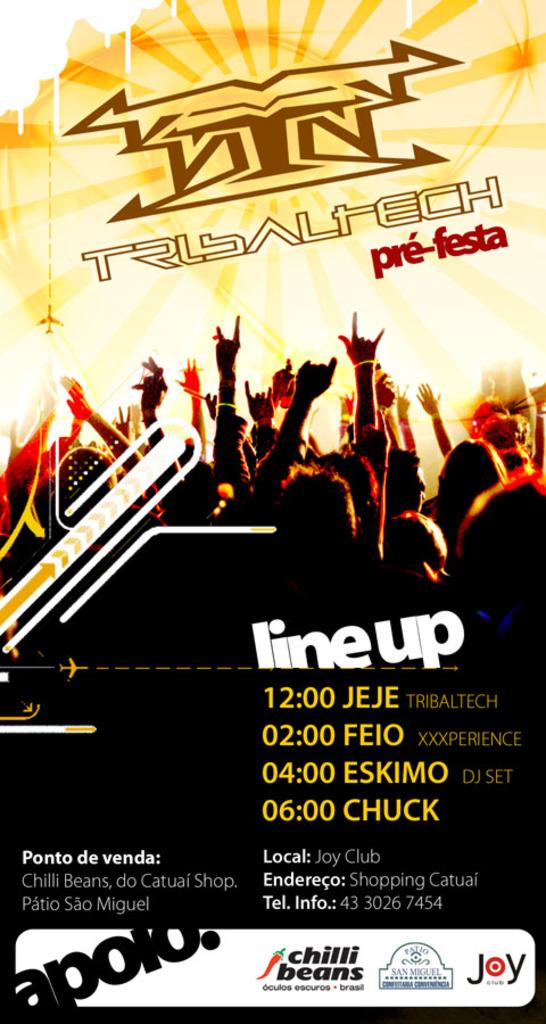What time is to the left of the word chuck?
Provide a succinct answer. 06:00. What is the name of the festival?
Your answer should be compact. Tribaltech. 